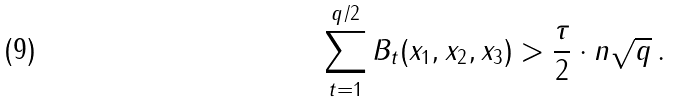<formula> <loc_0><loc_0><loc_500><loc_500>\sum _ { t = 1 } ^ { q / 2 } B _ { t } ( x _ { 1 } , x _ { 2 } , x _ { 3 } ) > \frac { \tau } { 2 } \cdot n \sqrt { q } \, .</formula> 